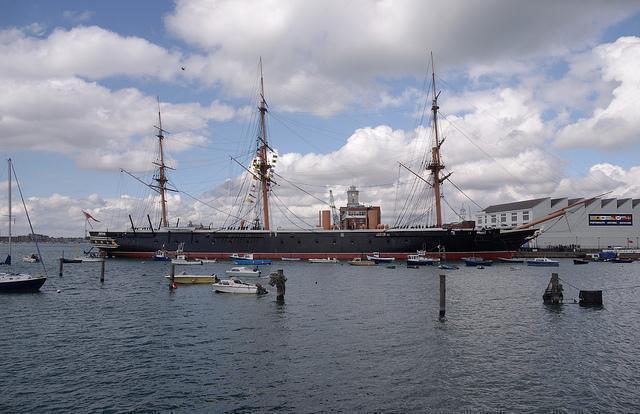What mode of transport is in the above picture?
Select the accurate answer and provide explanation: 'Answer: answer
Rationale: rationale.'
Options: Railway, air, water, road. Answer: water.
Rationale: Boats can currently only travel on water. 